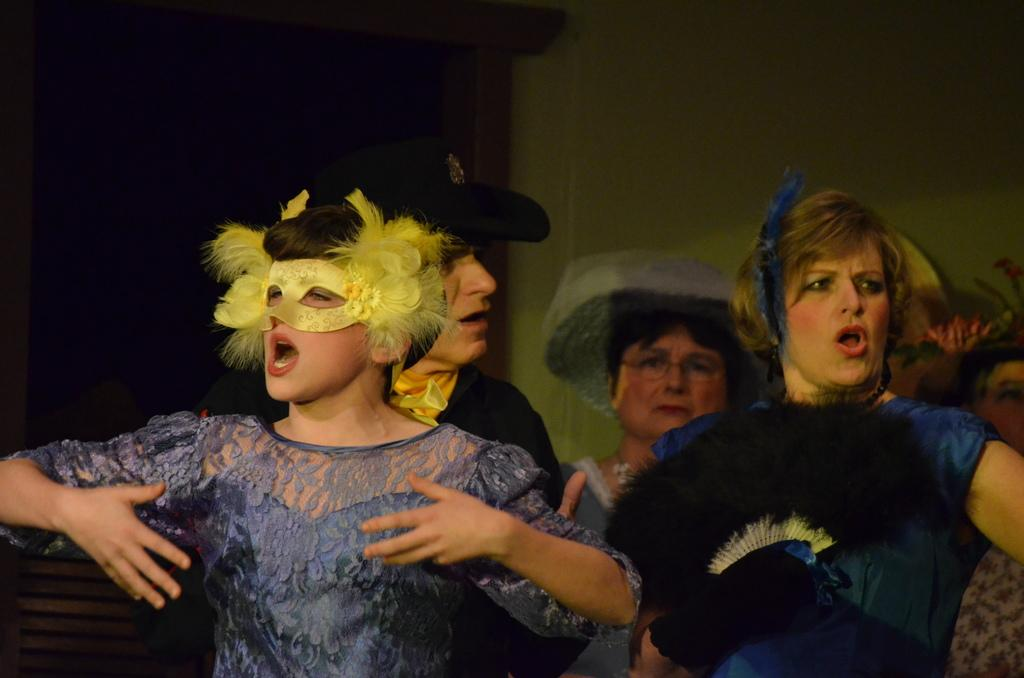Who is present in the image? There are women in the image. What are the women doing in the image? The women are dancing. What type of mountain can be seen in the background of the image? There is no mountain present in the image; it features women dancing. What kind of lace is being used to decorate the women's clothing in the image? There is no mention of lace or any specific clothing details in the image. 